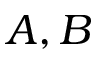<formula> <loc_0><loc_0><loc_500><loc_500>A , B</formula> 